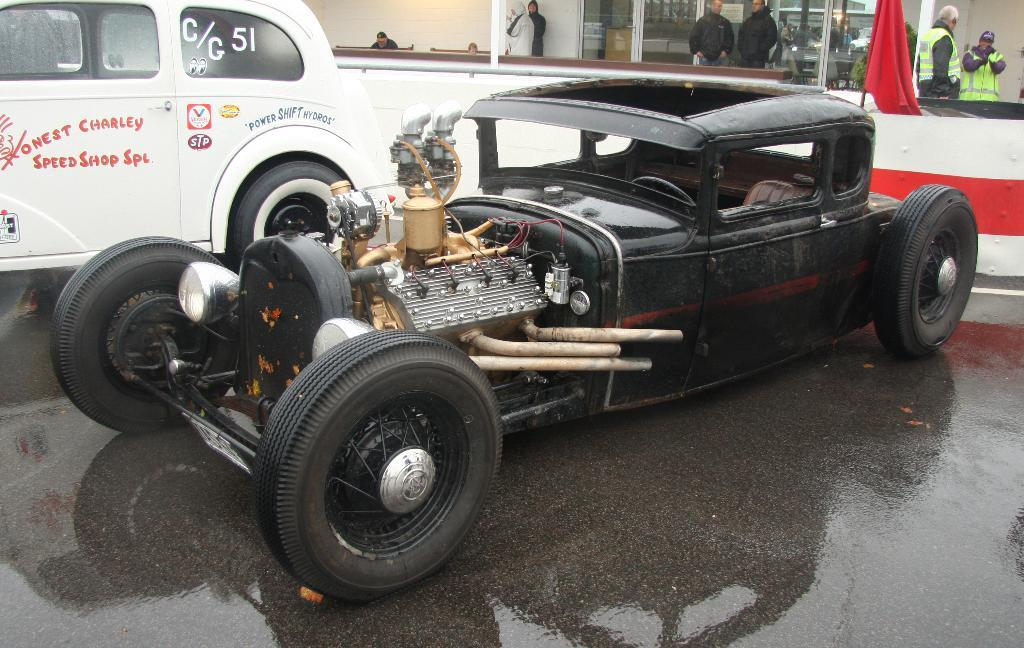What types of objects can be seen in the image? There are vehicles in the image. What can be seen in the background of the image? In the background, there are persons, a wall, a flag, and other objects. What is the surface at the bottom of the image? There is a floor at the bottom of the image. What type of wren can be seen perched on the flag in the image? There is no wren present in the image, and the flag is not depicted as having any bird perched on it. 